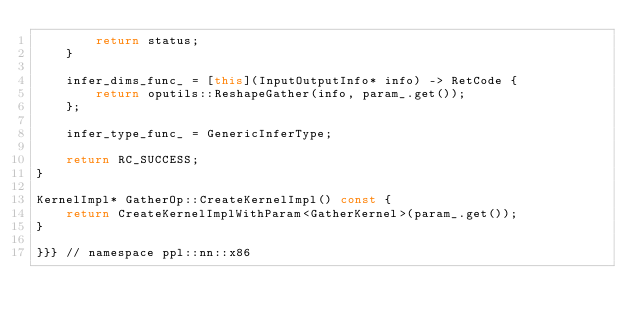<code> <loc_0><loc_0><loc_500><loc_500><_C++_>        return status;
    }

    infer_dims_func_ = [this](InputOutputInfo* info) -> RetCode {
        return oputils::ReshapeGather(info, param_.get());
    };

    infer_type_func_ = GenericInferType;

    return RC_SUCCESS;
}

KernelImpl* GatherOp::CreateKernelImpl() const {
    return CreateKernelImplWithParam<GatherKernel>(param_.get());
}

}}} // namespace ppl::nn::x86
</code> 